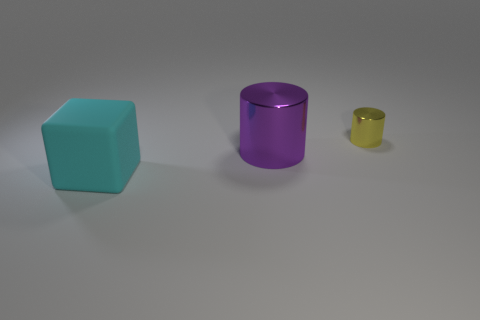Does the metal cylinder left of the yellow thing have the same color as the big object in front of the large purple cylinder?
Your answer should be very brief. No. How many large purple shiny cylinders are there?
Provide a succinct answer. 1. There is a big cyan rubber object; are there any large things in front of it?
Offer a very short reply. No. Is the big purple cylinder left of the yellow metal cylinder made of the same material as the object behind the purple metal cylinder?
Make the answer very short. Yes. Is the number of tiny cylinders that are left of the yellow metallic cylinder less than the number of small metal cylinders?
Make the answer very short. Yes. There is a shiny object in front of the small yellow thing; what is its color?
Give a very brief answer. Purple. What is the material of the thing that is left of the metallic cylinder in front of the yellow thing?
Give a very brief answer. Rubber. Are there any brown rubber cylinders of the same size as the yellow cylinder?
Offer a very short reply. No. What number of objects are shiny things to the right of the large shiny cylinder or shiny cylinders that are in front of the tiny shiny thing?
Provide a short and direct response. 2. Is the size of the metallic cylinder in front of the small metal cylinder the same as the metallic cylinder to the right of the big cylinder?
Give a very brief answer. No. 